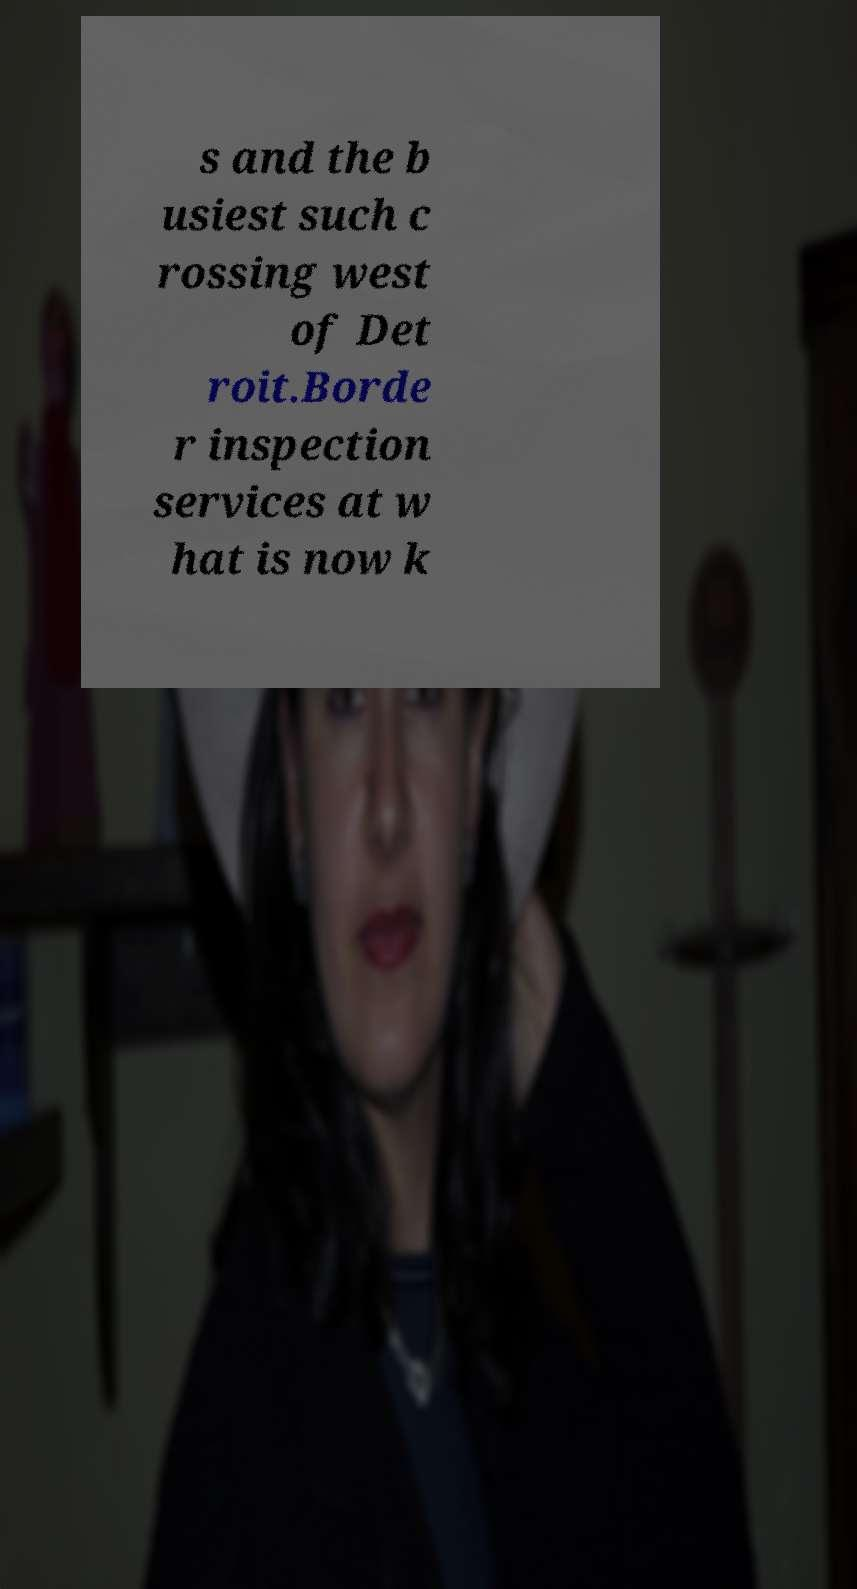Please identify and transcribe the text found in this image. s and the b usiest such c rossing west of Det roit.Borde r inspection services at w hat is now k 